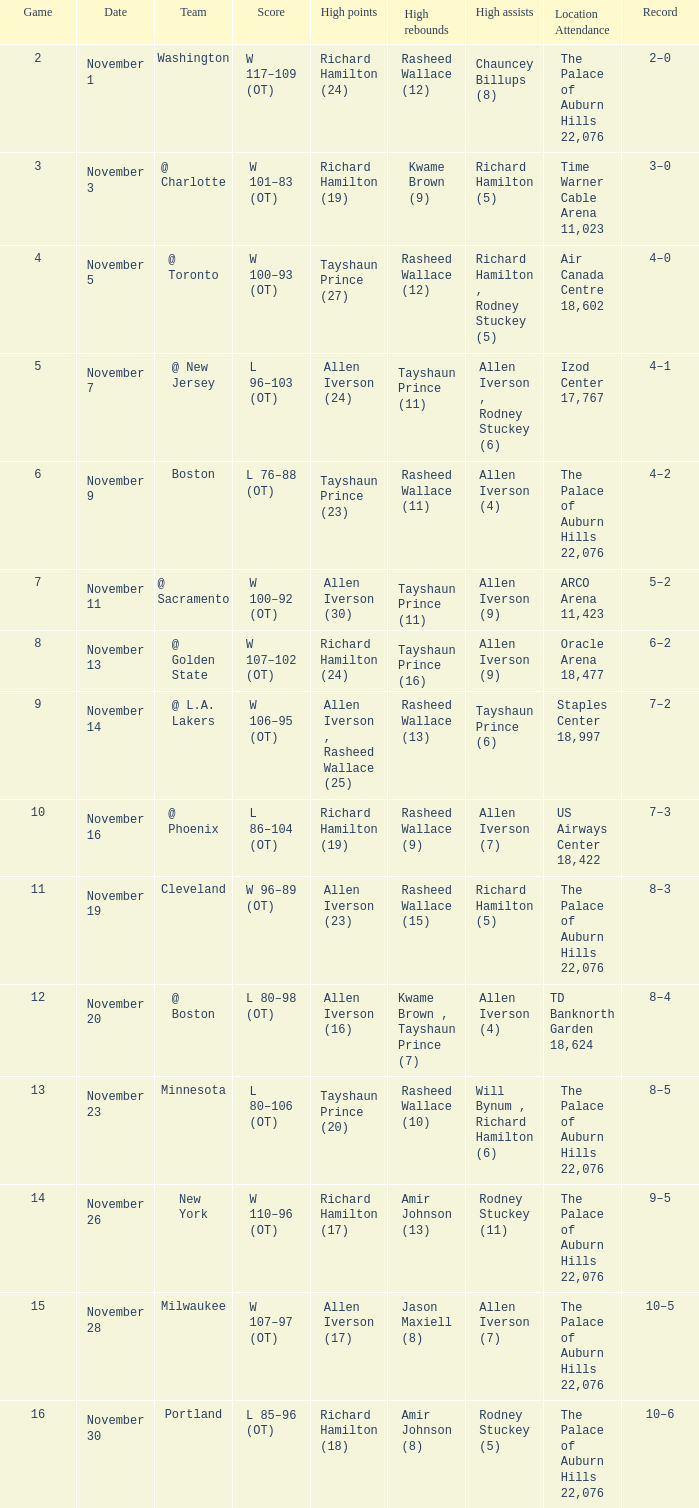What is High Points, when Game is less than 10, and when High Assists is "Chauncey Billups (8)"? Richard Hamilton (24). 